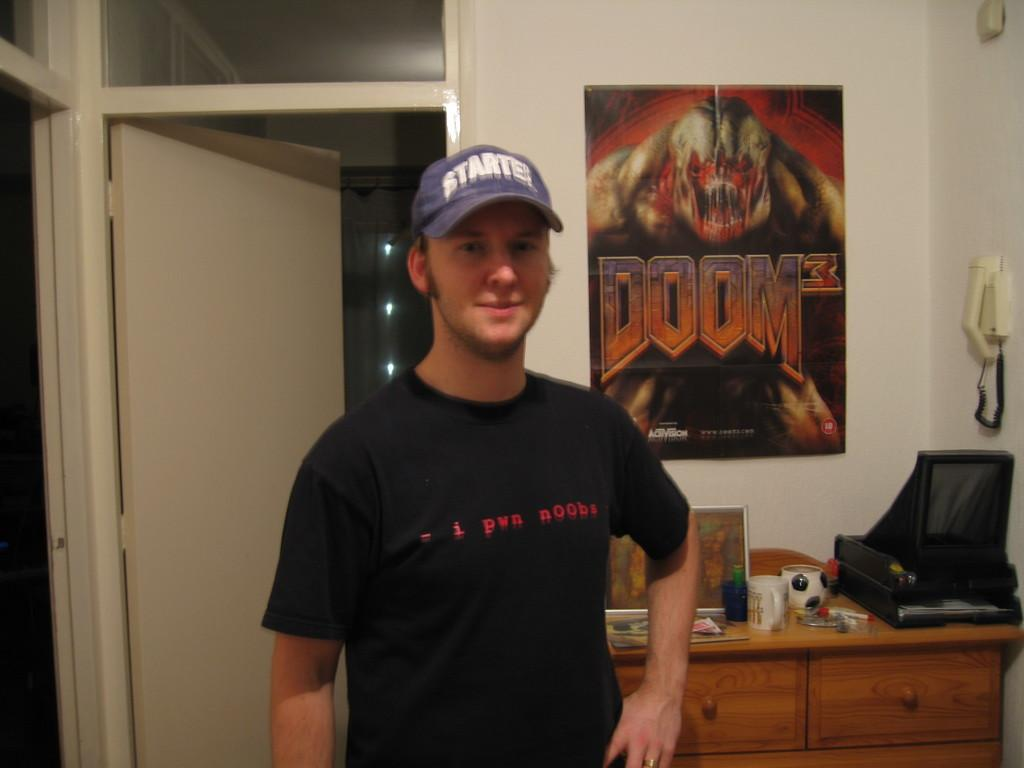<image>
Write a terse but informative summary of the picture. A man in a black shirt is is wearing a Starter hat. 